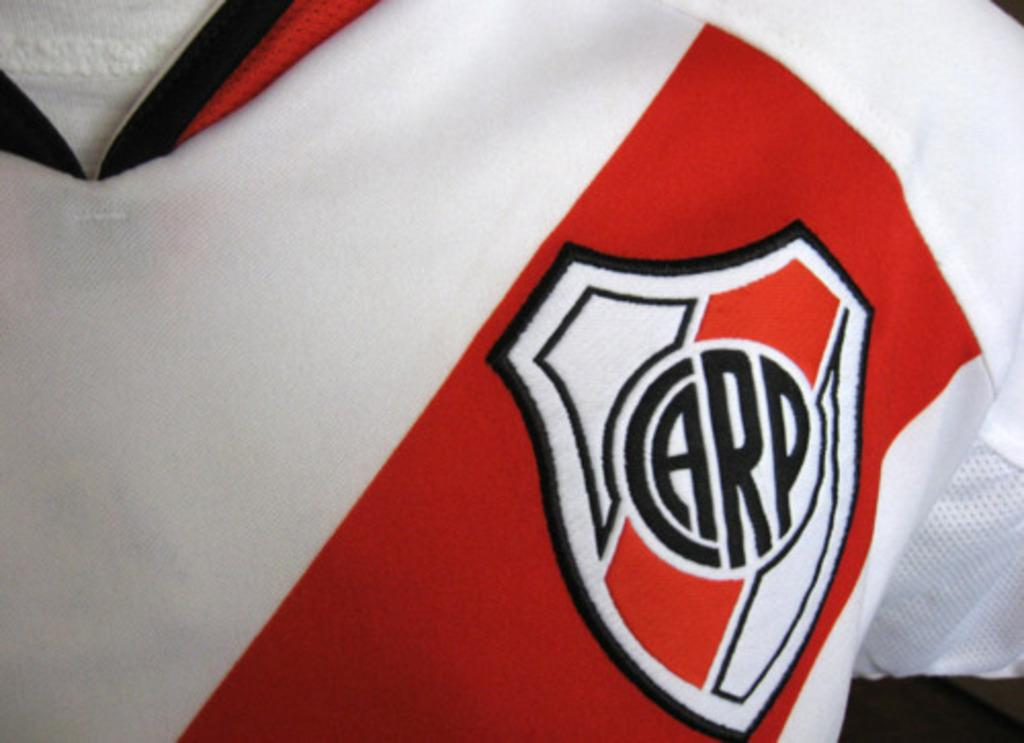<image>
Share a concise interpretation of the image provided. A shirt with a shield that says Carp sewn into it. 